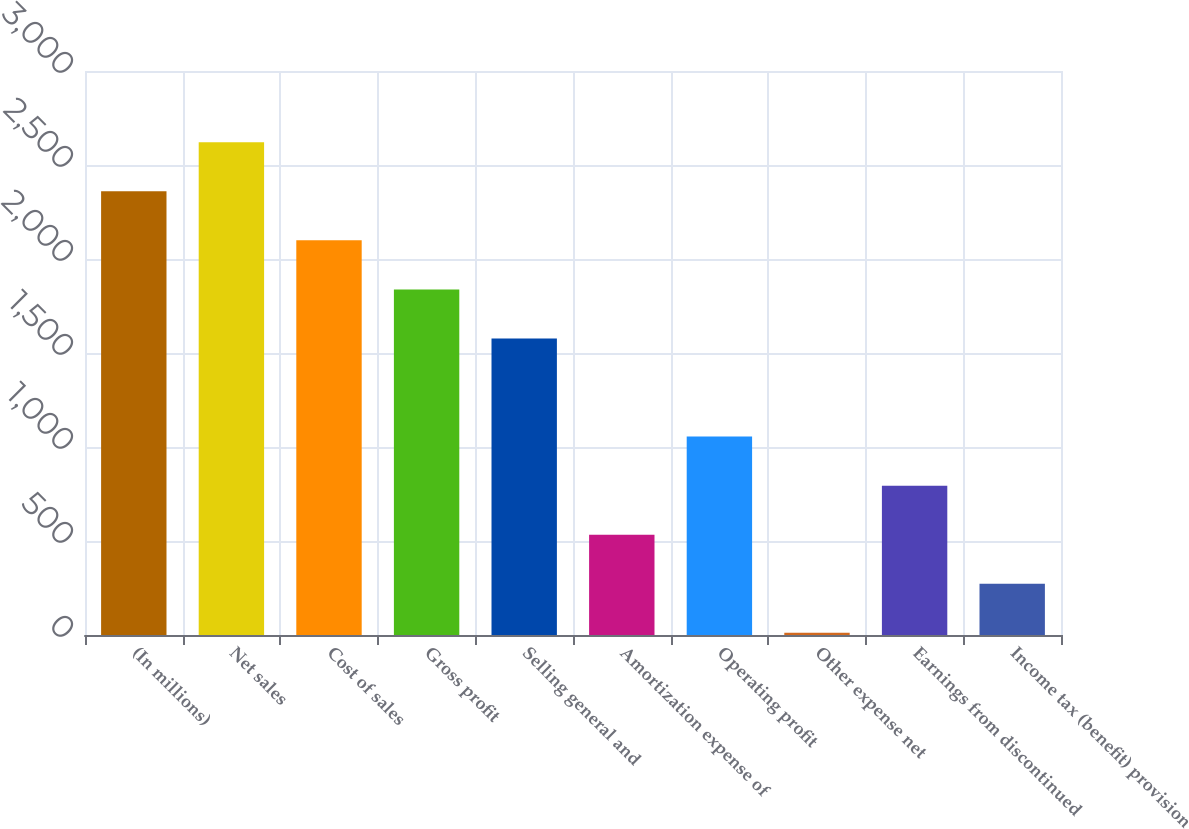Convert chart to OTSL. <chart><loc_0><loc_0><loc_500><loc_500><bar_chart><fcel>(In millions)<fcel>Net sales<fcel>Cost of sales<fcel>Gross profit<fcel>Selling general and<fcel>Amortization expense of<fcel>Operating profit<fcel>Other expense net<fcel>Earnings from discontinued<fcel>Income tax (benefit) provision<nl><fcel>2360.22<fcel>2621.2<fcel>2099.24<fcel>1838.26<fcel>1577.28<fcel>533.36<fcel>1055.32<fcel>11.4<fcel>794.34<fcel>272.38<nl></chart> 